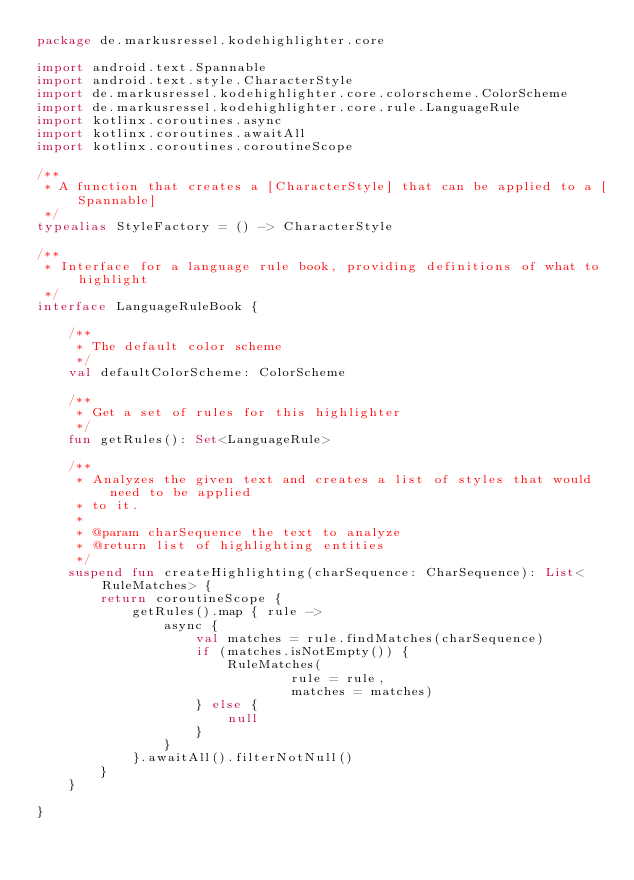<code> <loc_0><loc_0><loc_500><loc_500><_Kotlin_>package de.markusressel.kodehighlighter.core

import android.text.Spannable
import android.text.style.CharacterStyle
import de.markusressel.kodehighlighter.core.colorscheme.ColorScheme
import de.markusressel.kodehighlighter.core.rule.LanguageRule
import kotlinx.coroutines.async
import kotlinx.coroutines.awaitAll
import kotlinx.coroutines.coroutineScope

/**
 * A function that creates a [CharacterStyle] that can be applied to a [Spannable]
 */
typealias StyleFactory = () -> CharacterStyle

/**
 * Interface for a language rule book, providing definitions of what to highlight
 */
interface LanguageRuleBook {

    /**
     * The default color scheme
     */
    val defaultColorScheme: ColorScheme

    /**
     * Get a set of rules for this highlighter
     */
    fun getRules(): Set<LanguageRule>

    /**
     * Analyzes the given text and creates a list of styles that would need to be applied
     * to it.
     *
     * @param charSequence the text to analyze
     * @return list of highlighting entities
     */
    suspend fun createHighlighting(charSequence: CharSequence): List<RuleMatches> {
        return coroutineScope {
            getRules().map { rule ->
                async {
                    val matches = rule.findMatches(charSequence)
                    if (matches.isNotEmpty()) {
                        RuleMatches(
                                rule = rule,
                                matches = matches)
                    } else {
                        null
                    }
                }
            }.awaitAll().filterNotNull()
        }
    }

}</code> 